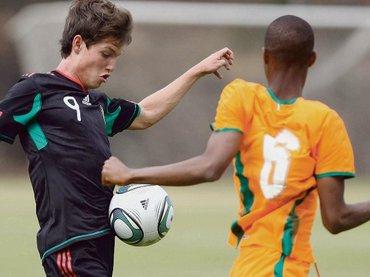What part of his body is hitting the ball?
Give a very brief answer. Stomach. What color is the man on the rights shirt?
Answer briefly. Orange. What is the jersey number?
Concise answer only. 6. How many men in the picture?
Concise answer only. 2. What color is the ball?
Concise answer only. White and green. What sport are the men playing?
Write a very short answer. Soccer. What numbers are on their shirts?
Give a very brief answer. 9 and 6. 